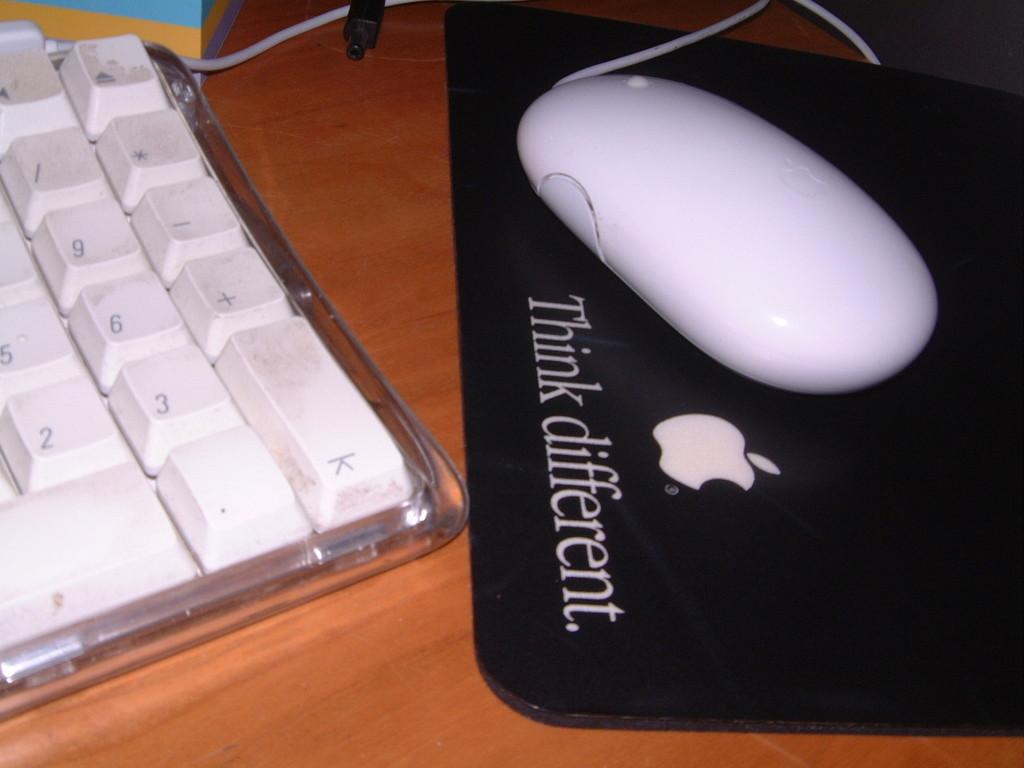What numbers do you see on the keypad?
Make the answer very short. 2, 3, 5, 6, 9. 